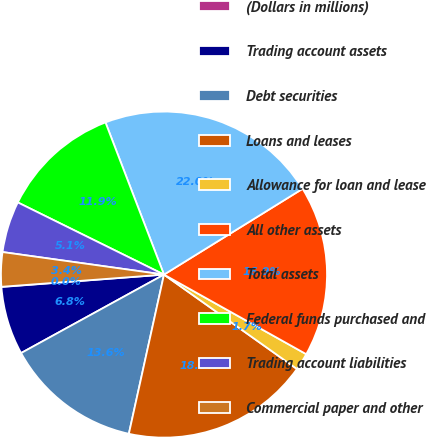Convert chart. <chart><loc_0><loc_0><loc_500><loc_500><pie_chart><fcel>(Dollars in millions)<fcel>Trading account assets<fcel>Debt securities<fcel>Loans and leases<fcel>Allowance for loan and lease<fcel>All other assets<fcel>Total assets<fcel>Federal funds purchased and<fcel>Trading account liabilities<fcel>Commercial paper and other<nl><fcel>0.02%<fcel>6.78%<fcel>13.55%<fcel>18.63%<fcel>1.71%<fcel>16.94%<fcel>22.02%<fcel>11.86%<fcel>5.09%<fcel>3.4%<nl></chart> 